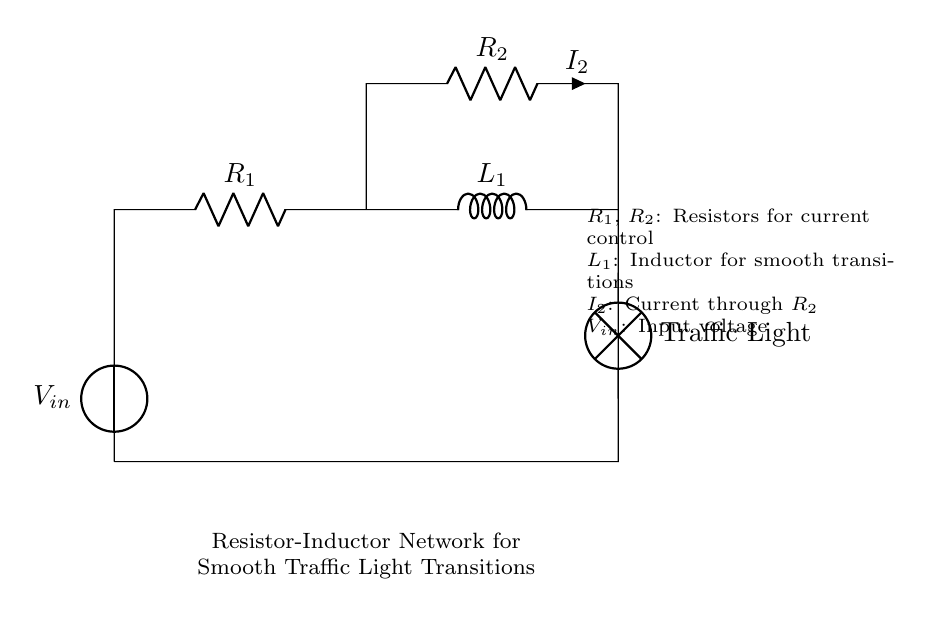What is the function of R1 in this circuit? R1 is a resistor that helps control the current flowing through the circuit, affecting the overall behavior of the traffic light.
Answer: Current control What component is used for smooth transitions in this circuit? The inductor L1 is designed to provide inertia in the electrical current, allowing for smoother transitions between traffic light states.
Answer: Inductor What is the role of the traffic light in this circuit? The traffic light serves as an output device that indicates the state of the traffic control system, which is influenced by the inputs from the resistor-inductor network.
Answer: Output device What is the voltage source labeled as? The voltage source is labeled as Vin, which supplies the necessary energy for the circuit to function and actuate the traffic light.
Answer: Vin What does the current through R2 signify? The current through R2, denoted as I2, indicates the amount of electrical current flowing through that resistor, which affects the operation of the traffic light.
Answer: I2 How do the resistors R1 and R2 interact in this circuit? Resistors R1 and R2 collectively manage the current in the circuit; R1 sets the initial current while R2 influences the current that affects the traffic light operation, creating a balanced functioning of the network.
Answer: Current management What effect does the inductor L1 have on the circuit's response time? The inductor L1 introduces a time delay in the circuit's response due to its property of opposing changes in current, resulting in smoother transitions of the traffic light.
Answer: Response time delay 